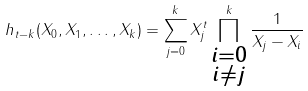Convert formula to latex. <formula><loc_0><loc_0><loc_500><loc_500>h _ { t - k } ( X _ { 0 } , X _ { 1 } , \dots , X _ { k } ) = \sum _ { j = 0 } ^ { k } X _ { j } ^ { t } \prod _ { \substack { i = 0 \\ i \neq j } } ^ { k } \frac { 1 } { X _ { j } - X _ { i } }</formula> 